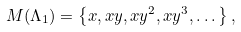<formula> <loc_0><loc_0><loc_500><loc_500>M ( \Lambda _ { 1 } ) = \left \{ x , x y , x y ^ { 2 } , x y ^ { 3 } , \dots \right \} ,</formula> 